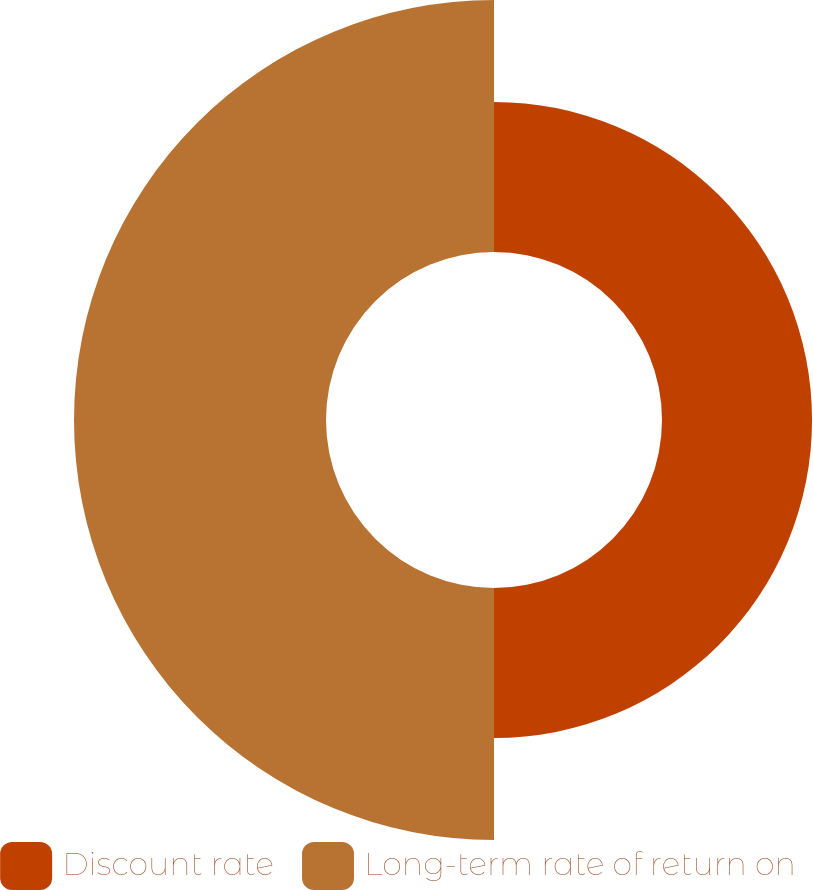Convert chart to OTSL. <chart><loc_0><loc_0><loc_500><loc_500><pie_chart><fcel>Discount rate<fcel>Long-term rate of return on<nl><fcel>37.32%<fcel>62.68%<nl></chart> 